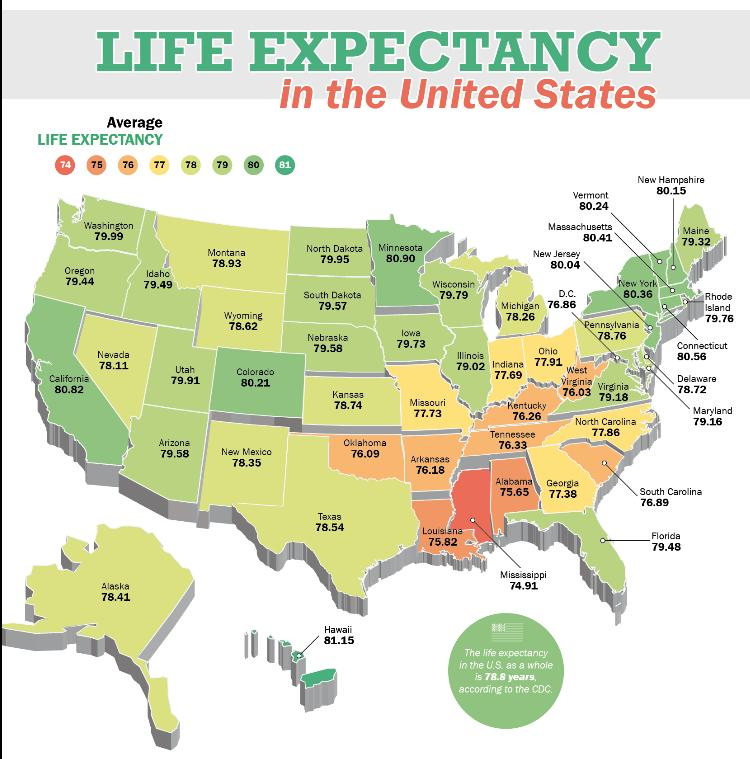List a handful of essential elements in this visual. Hawaii has a higher average life expectancy than the state with the lowest average life expectancy. If the color of a state is red, then the average life expectancy is 74 years. Out of the 50 states in the United States, how many have life expectancy above 81 years old? The average life expectancy if the color of the state is yellow is 77. Mississippi has a lower-than-average life expectancy, as stated by the data. 